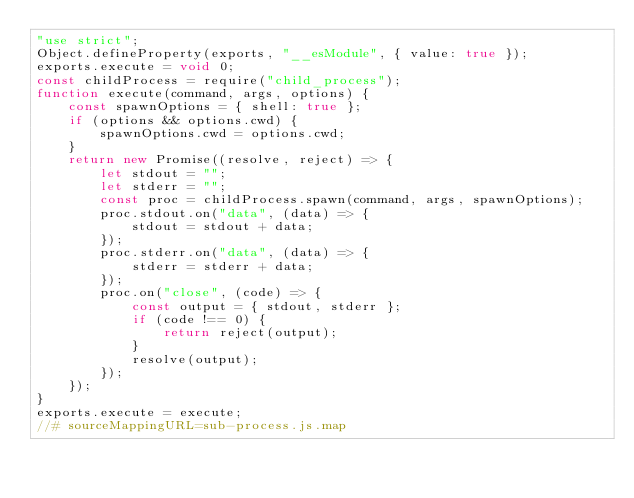<code> <loc_0><loc_0><loc_500><loc_500><_JavaScript_>"use strict";
Object.defineProperty(exports, "__esModule", { value: true });
exports.execute = void 0;
const childProcess = require("child_process");
function execute(command, args, options) {
    const spawnOptions = { shell: true };
    if (options && options.cwd) {
        spawnOptions.cwd = options.cwd;
    }
    return new Promise((resolve, reject) => {
        let stdout = "";
        let stderr = "";
        const proc = childProcess.spawn(command, args, spawnOptions);
        proc.stdout.on("data", (data) => {
            stdout = stdout + data;
        });
        proc.stderr.on("data", (data) => {
            stderr = stderr + data;
        });
        proc.on("close", (code) => {
            const output = { stdout, stderr };
            if (code !== 0) {
                return reject(output);
            }
            resolve(output);
        });
    });
}
exports.execute = execute;
//# sourceMappingURL=sub-process.js.map</code> 